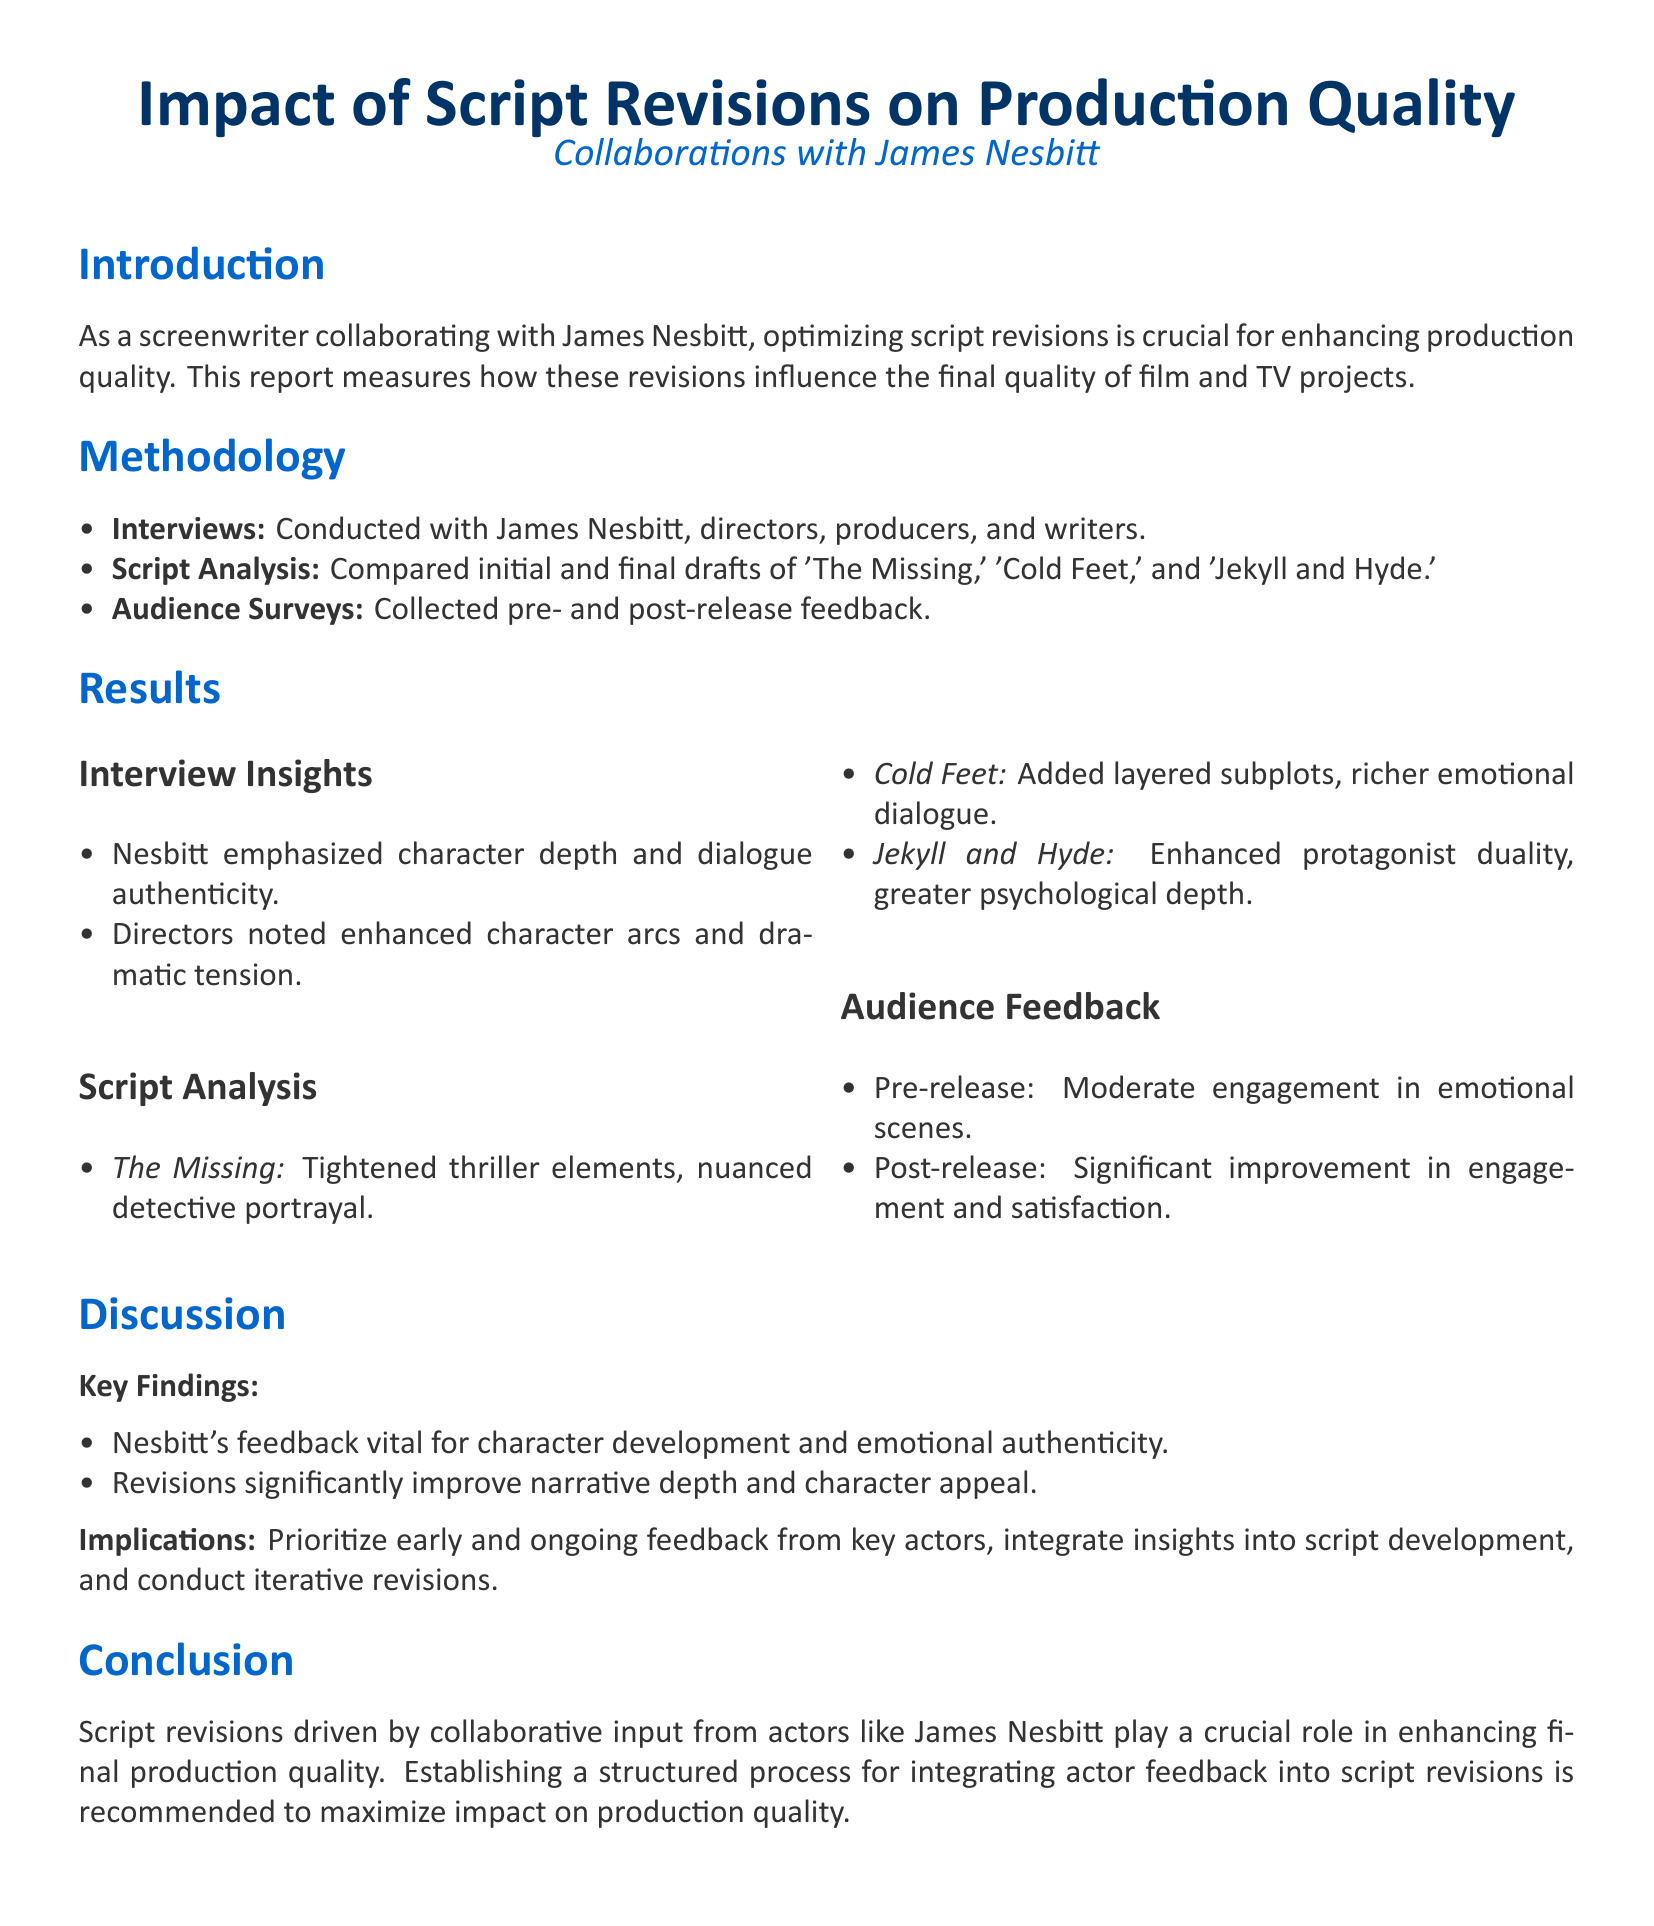What is the title of the report? The title of the report is prominently displayed at the beginning of the document.
Answer: Impact of Script Revisions on Production Quality Who is the main collaborator mentioned in the report? The report specifically highlights a collaboration with a notable actor.
Answer: James Nesbitt What type of analysis was conducted on scripts? The methodology section specifies a particular type of analytical approach to the scripts involved.
Answer: Script Analysis What was the audience's pre-release feedback regarding engagement? The result section discusses the audience's reaction to the emotional scenes prior to the release.
Answer: Moderate engagement Which project is noted for enhanced protagonist duality? The script analysis section lists the projects, highlighting this particular aspect for one of them.
Answer: Jekyll and Hyde What is identified as vital for character development according to Nesbitt? Insights from interviews in the results section describe this aspect of the character work.
Answer: Feedback What should be prioritized according to the implications section? The discussion section suggests a focus for improving script quality based on collaborative efforts.
Answer: Early and ongoing feedback What significant change was noted in audience satisfaction post-release? Audience feedback results indicate a change in their overall experience after viewing the projects.
Answer: Significant improvement What is a recommended action for maximizing impact on production quality? The conclusion presents a specific recommendation based on the findings of the report.
Answer: Establishing a structured process 